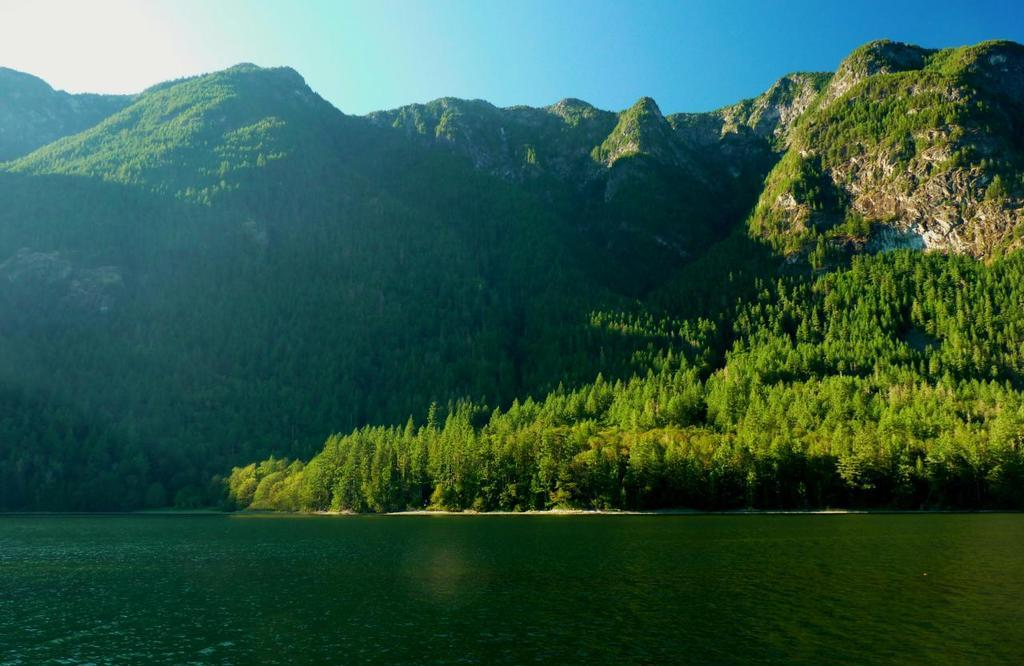What type of natural environment is depicted in the image? The image features trees and hills, indicating a natural environment. What can be seen at the bottom of the image? There is water visible at the bottom of the image. What is visible at the top of the image? The sky is visible at the top of the image. What type of leather is being tested in the image? There is no leather or testing process present in the image. 